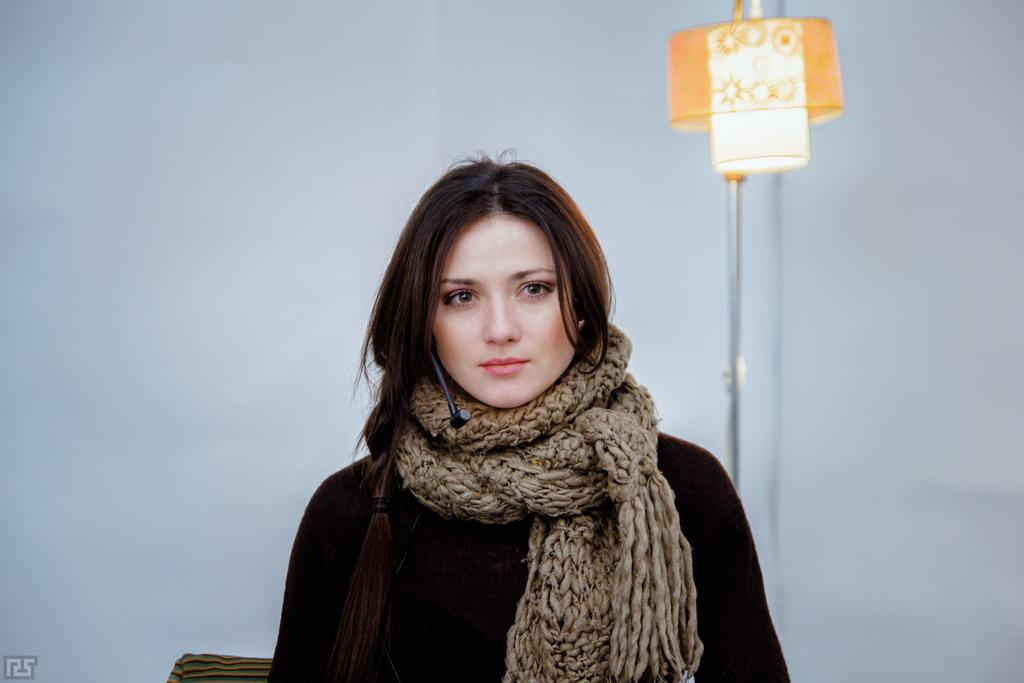Who or what is present in the image? There is a person in the image. What is the person wearing? The person is wearing a black and brown color dress. What can be seen in the background of the image? There is a lamp and a white wall in the background of the image. What type of plate is being used by the person in the image? There is no plate visible in the image; the person is not interacting with any plate. 